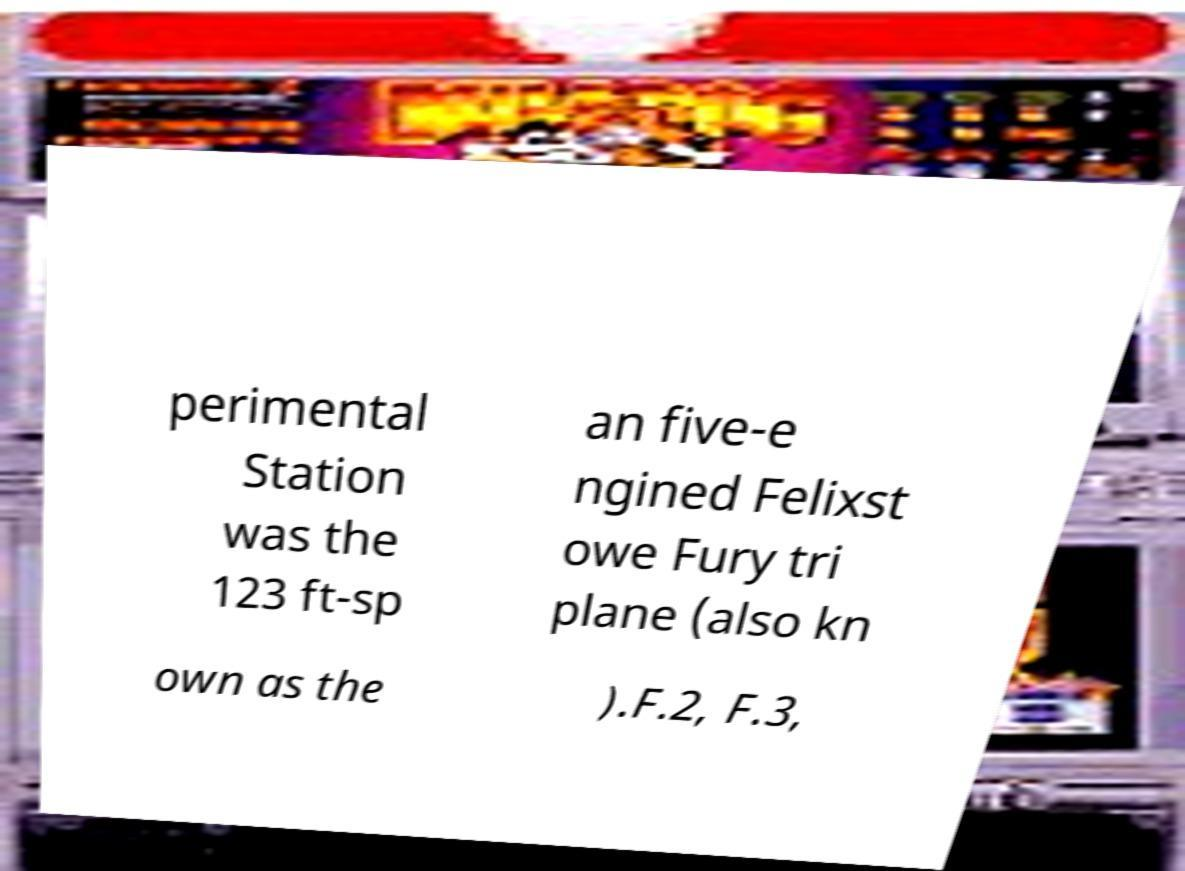Could you extract and type out the text from this image? perimental Station was the 123 ft-sp an five-e ngined Felixst owe Fury tri plane (also kn own as the ).F.2, F.3, 